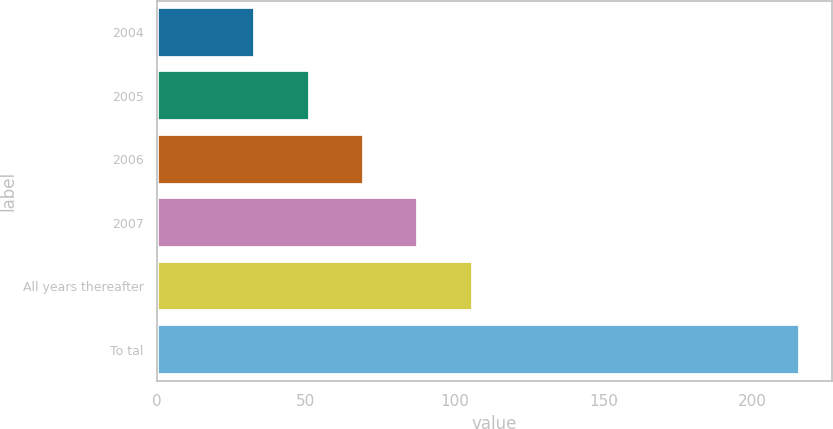Convert chart to OTSL. <chart><loc_0><loc_0><loc_500><loc_500><bar_chart><fcel>2004<fcel>2005<fcel>2006<fcel>2007<fcel>All years thereafter<fcel>To tal<nl><fcel>33<fcel>51.3<fcel>69.6<fcel>87.9<fcel>106.2<fcel>216<nl></chart> 